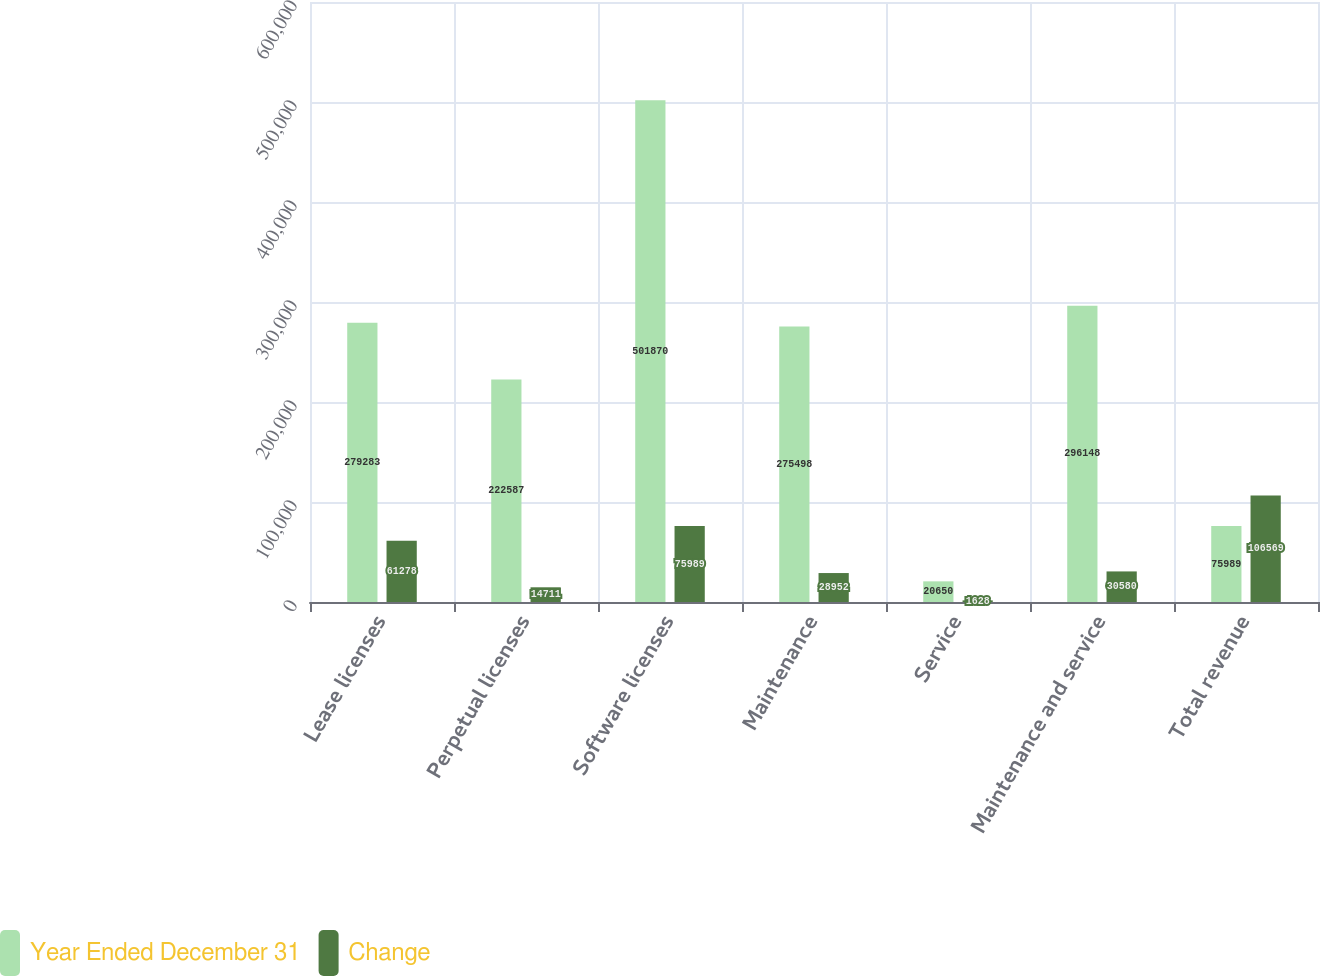Convert chart. <chart><loc_0><loc_0><loc_500><loc_500><stacked_bar_chart><ecel><fcel>Lease licenses<fcel>Perpetual licenses<fcel>Software licenses<fcel>Maintenance<fcel>Service<fcel>Maintenance and service<fcel>Total revenue<nl><fcel>Year Ended December 31<fcel>279283<fcel>222587<fcel>501870<fcel>275498<fcel>20650<fcel>296148<fcel>75989<nl><fcel>Change<fcel>61278<fcel>14711<fcel>75989<fcel>28952<fcel>1628<fcel>30580<fcel>106569<nl></chart> 